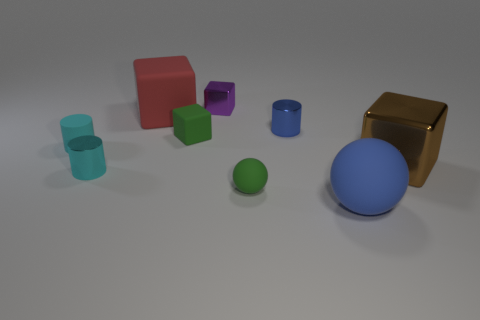Add 1 red blocks. How many objects exist? 10 Subtract all spheres. How many objects are left? 7 Subtract all large yellow shiny cylinders. Subtract all large blue matte balls. How many objects are left? 8 Add 1 small green rubber blocks. How many small green rubber blocks are left? 2 Add 2 brown metal cubes. How many brown metal cubes exist? 3 Subtract 0 red cylinders. How many objects are left? 9 